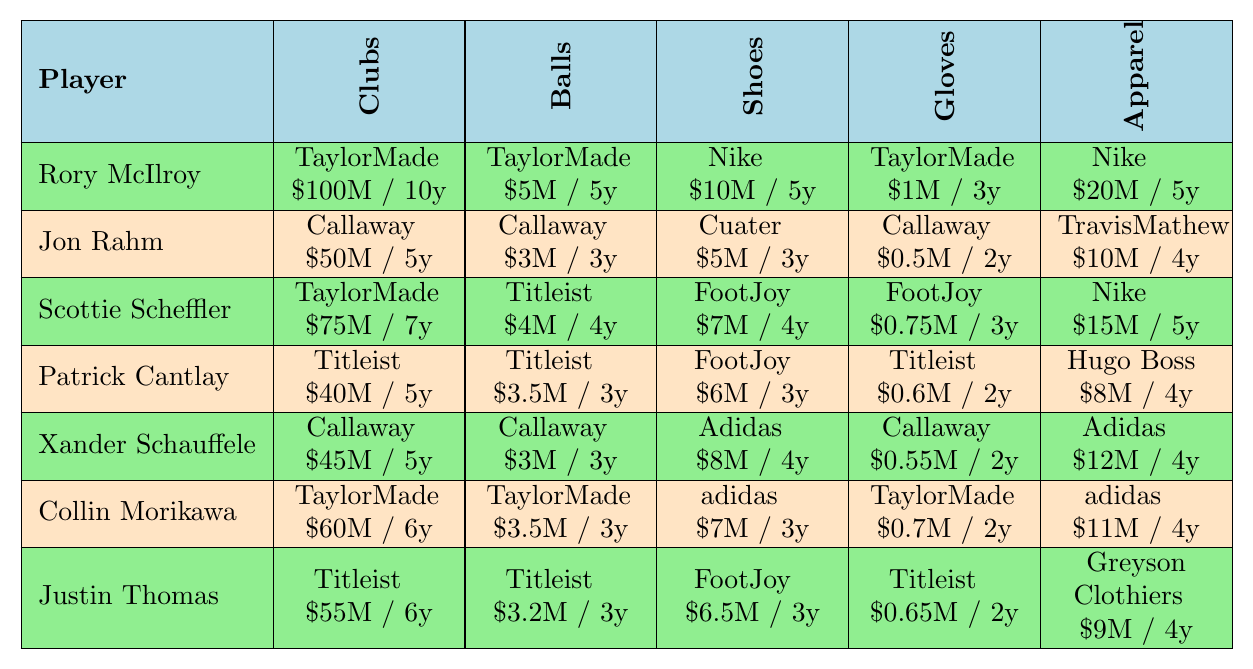What brand sponsors Rory McIlroy for clubs? According to the table, Rory McIlroy is sponsored by TaylorMade for clubs.
Answer: TaylorMade How much is Jon Rahm's sponsorship deal for shoes? The table shows that Jon Rahm's sponsorship deal for shoes is with Cuater for $5 million over 3 years.
Answer: $5M / 3y Which player has the highest club sponsorship deal value? Scottie Scheffler has the highest club sponsorship deal with TaylorMade worth $75 million over 7 years, according to the table.
Answer: Scottie Scheffler What is the total sponsorship value for Collin Morikawa's apparel and shoes? The sponsorship values are $11 million for apparel and $7 million for shoes. Summing them gives $11M + $7M = $18M.
Answer: $18M Did Patrick Cantlay receive any sponsorship for gloves? Yes, the table indicates that Patrick Cantlay has a glove sponsorship deal with Titleist worth $600,000 over 2 years.
Answer: Yes Which player has a sponsorship deal with Adidas and for what category? Xander Schauffele has a sponsorship deal with Adidas for shoes valued at $8 million over 4 years.
Answer: Shoes What is the average duration of sponsorship deals for Justin Thomas? The duration of his deals is 6, 3, 3, 2, and 4 years. Summing these gives 18 years, and averaging over 5 deals gives 18/5 = 3.6 years.
Answer: 3.6 years Is there any player sponsored by both TaylorMade and Titleist? Yes, both Collin Morikawa and Scottie Scheffler have sponsorships from TaylorMade, while Justin Thomas has a deal with Titleist.
Answer: Yes How many players have Callaway as their ball sponsor? Based on the table, both Jon Rahm and Xander Schauffele are sponsored by Callaway for balls, totaling 2 players.
Answer: 2 players What is the difference between the total sponsorship values of Rory McIlroy and Patrick Cantlay? Rory McIlroy's total value is $100M + $5M + $10M + $1M + $20M = $136M; Patrick Cantlay's total is $40M + $3.5M + $6M + $0.6M + $8M = $58.1M. The difference is $136M - $58.1M = $77.9M.
Answer: $77.9M 